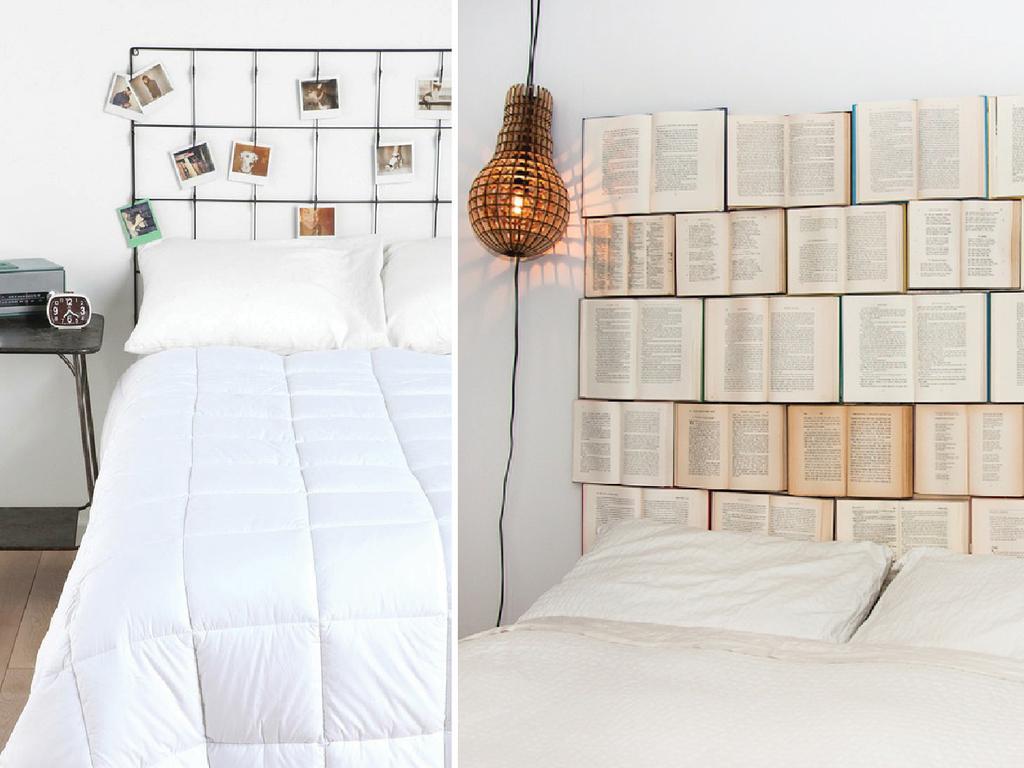Please provide a concise description of this image. In this an image with collage in which we can see a bed with some pillows, a table with a clock and a device on it and a group of photos on a wall. We can also see a lamp with wires, a group of books and a bed with pillows. 